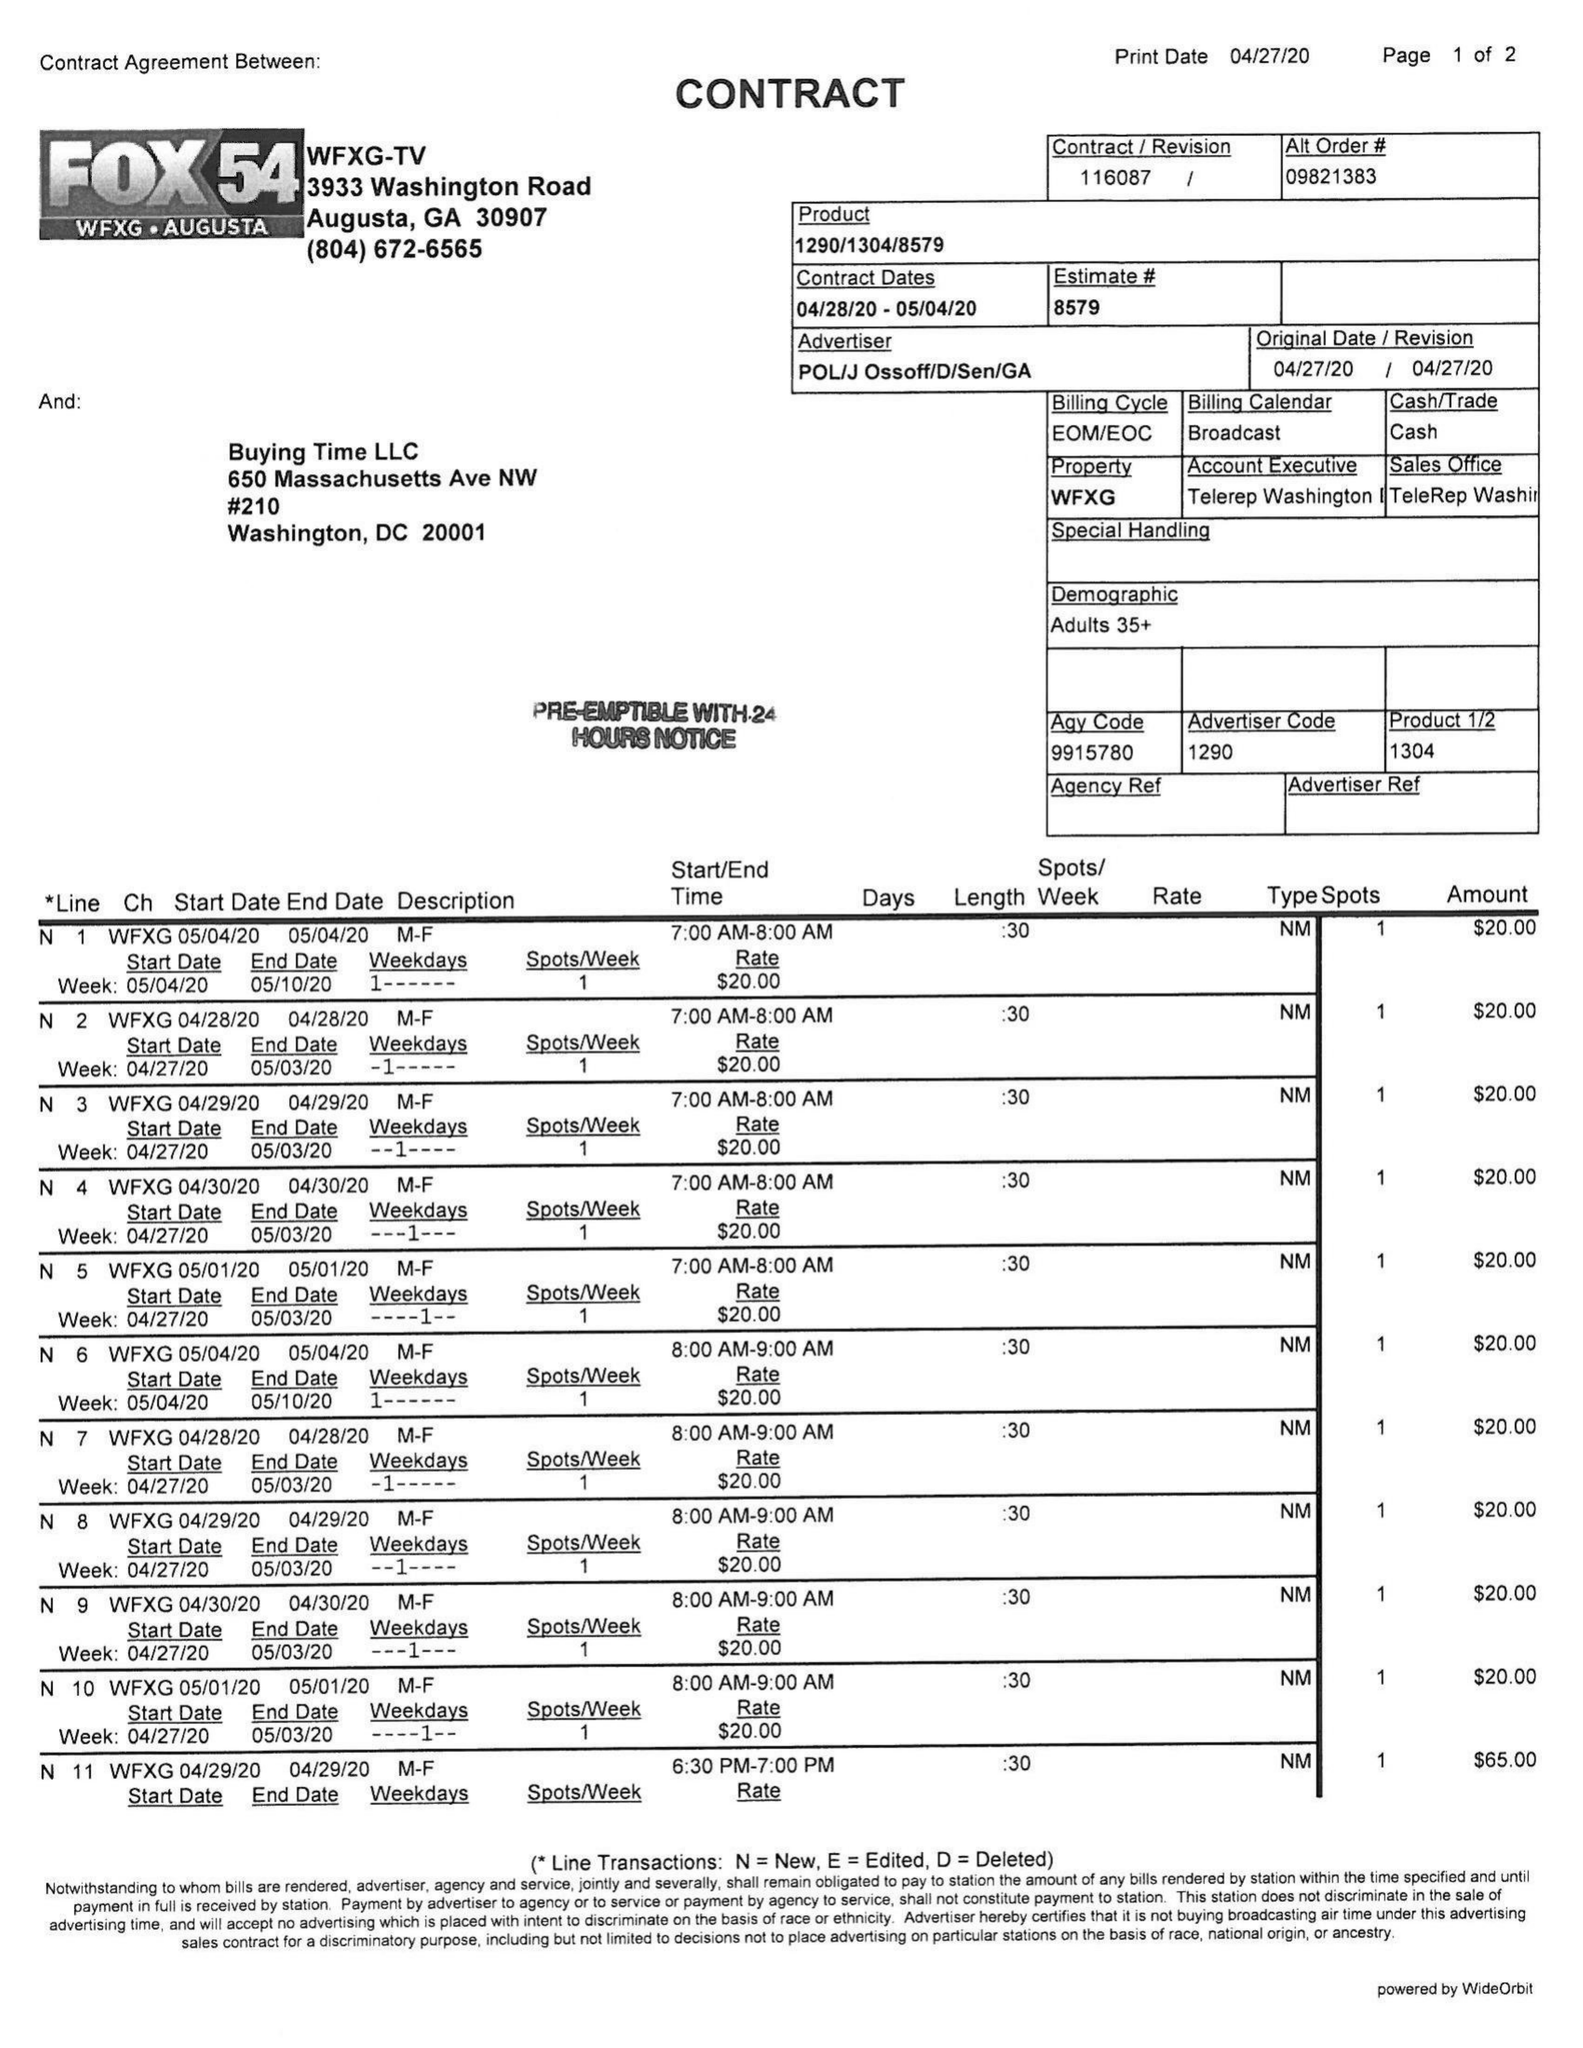What is the value for the gross_amount?
Answer the question using a single word or phrase. 585.00 